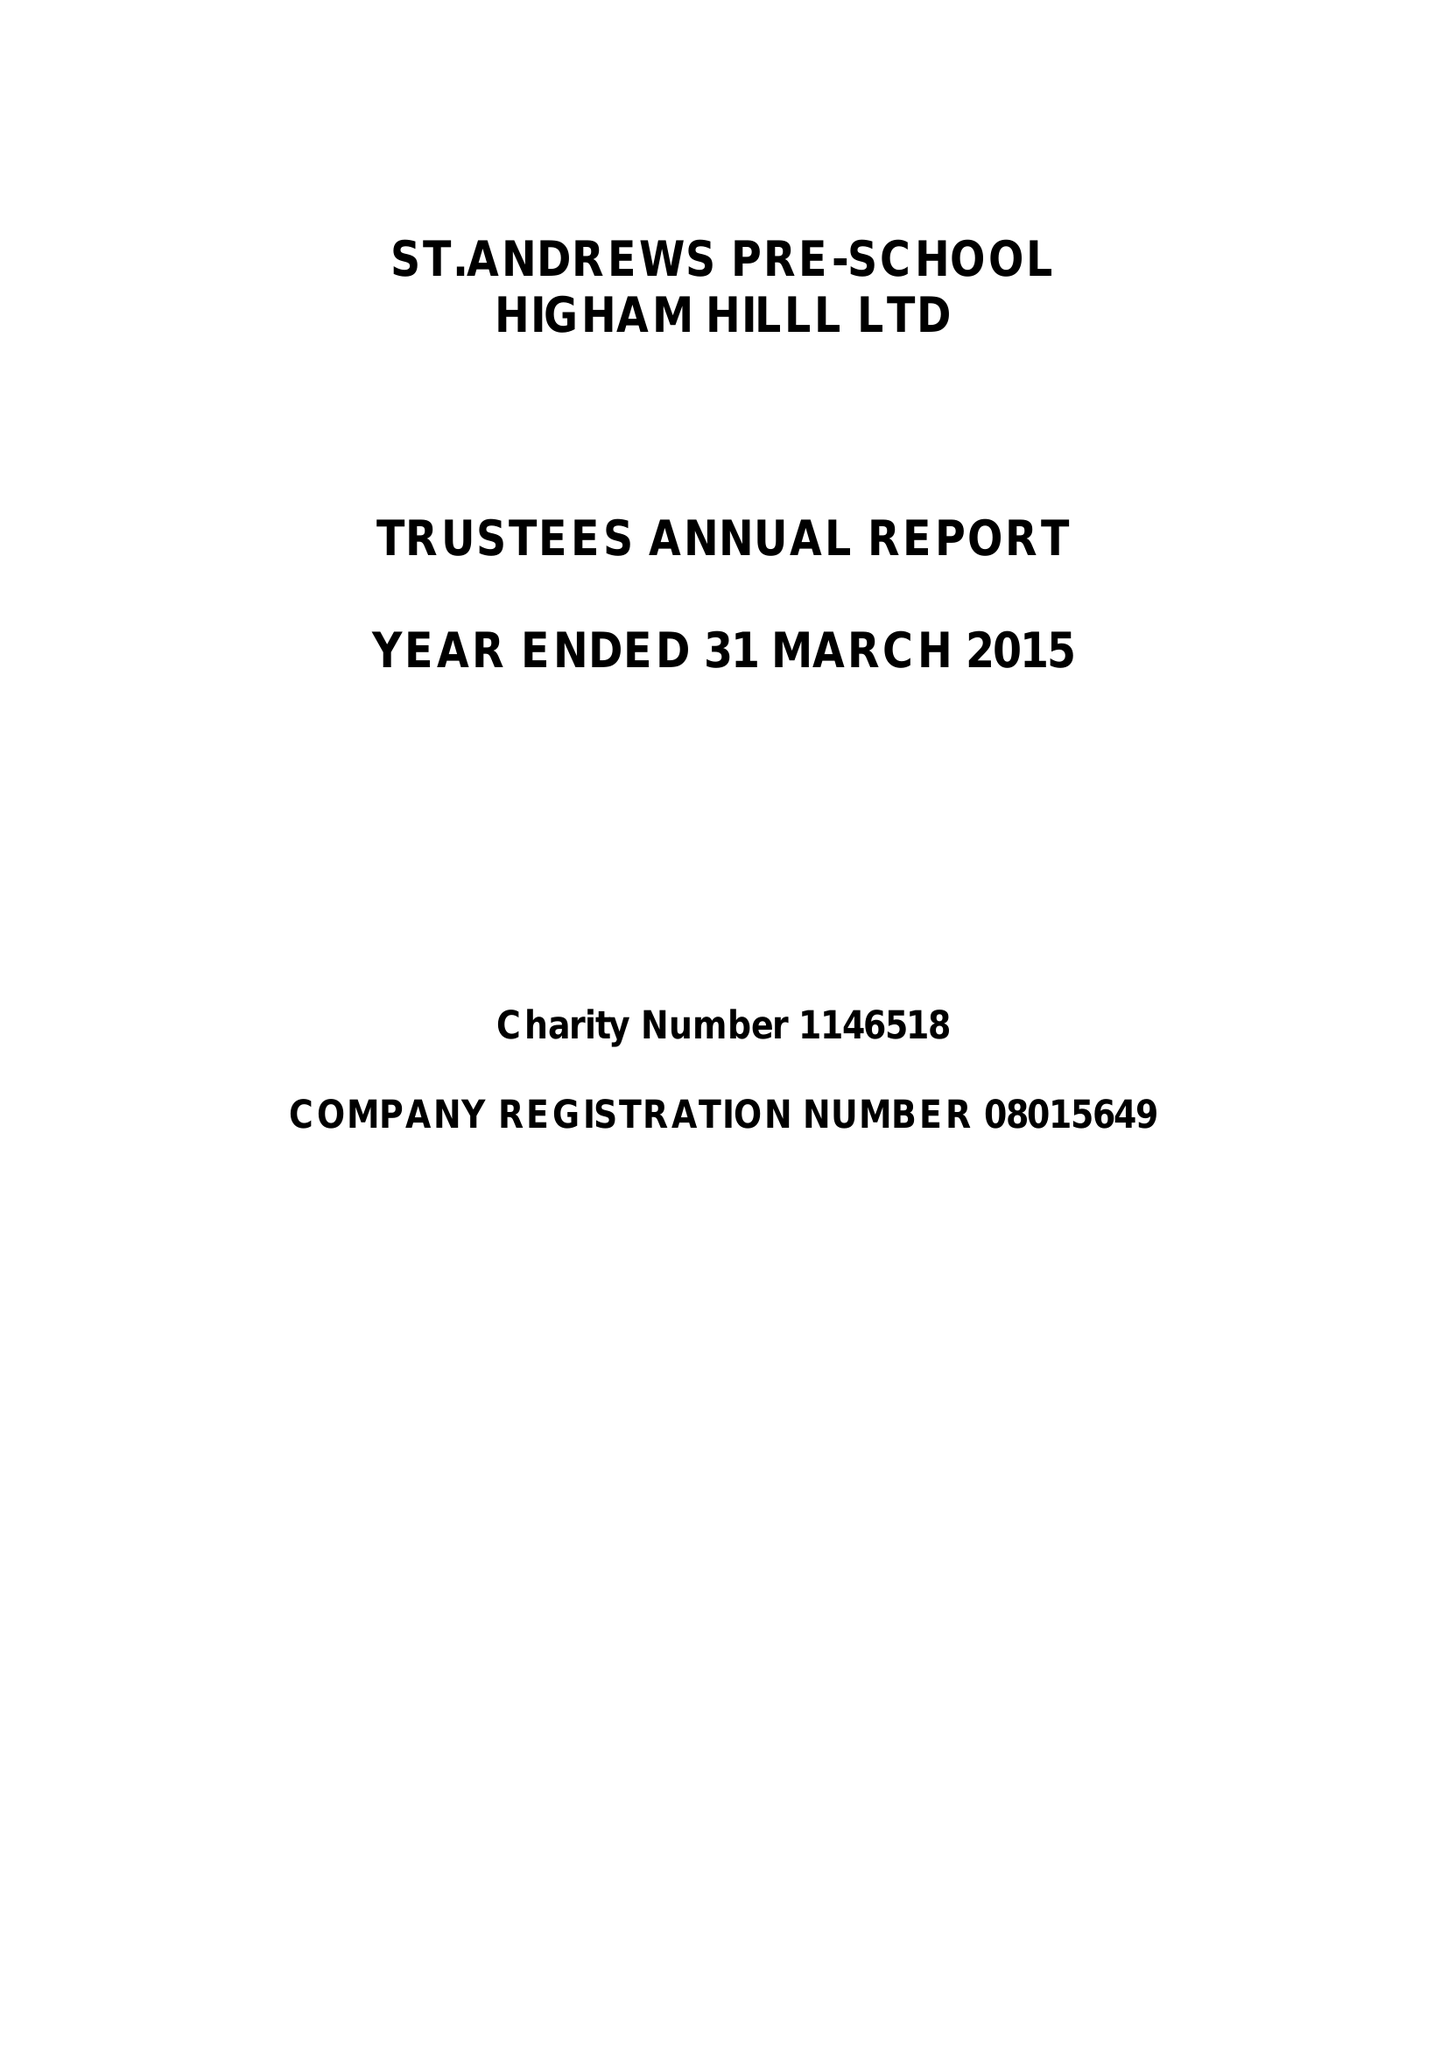What is the value for the address__post_town?
Answer the question using a single word or phrase. LONDON 